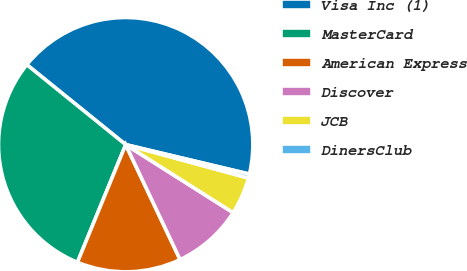Convert chart. <chart><loc_0><loc_0><loc_500><loc_500><pie_chart><fcel>Visa Inc (1)<fcel>MasterCard<fcel>American Express<fcel>Discover<fcel>JCB<fcel>DinersClub<nl><fcel>42.9%<fcel>29.63%<fcel>13.23%<fcel>8.99%<fcel>4.75%<fcel>0.51%<nl></chart> 